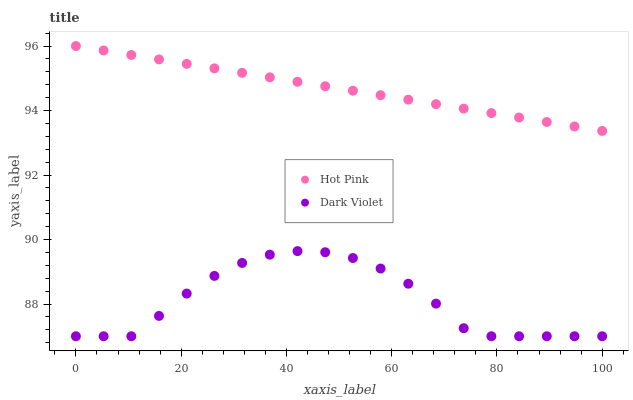Does Dark Violet have the minimum area under the curve?
Answer yes or no. Yes. Does Hot Pink have the maximum area under the curve?
Answer yes or no. Yes. Does Dark Violet have the maximum area under the curve?
Answer yes or no. No. Is Hot Pink the smoothest?
Answer yes or no. Yes. Is Dark Violet the roughest?
Answer yes or no. Yes. Is Dark Violet the smoothest?
Answer yes or no. No. Does Dark Violet have the lowest value?
Answer yes or no. Yes. Does Hot Pink have the highest value?
Answer yes or no. Yes. Does Dark Violet have the highest value?
Answer yes or no. No. Is Dark Violet less than Hot Pink?
Answer yes or no. Yes. Is Hot Pink greater than Dark Violet?
Answer yes or no. Yes. Does Dark Violet intersect Hot Pink?
Answer yes or no. No. 